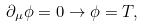<formula> <loc_0><loc_0><loc_500><loc_500>\partial _ { \mu } \phi = 0 \rightarrow \phi = T ,</formula> 